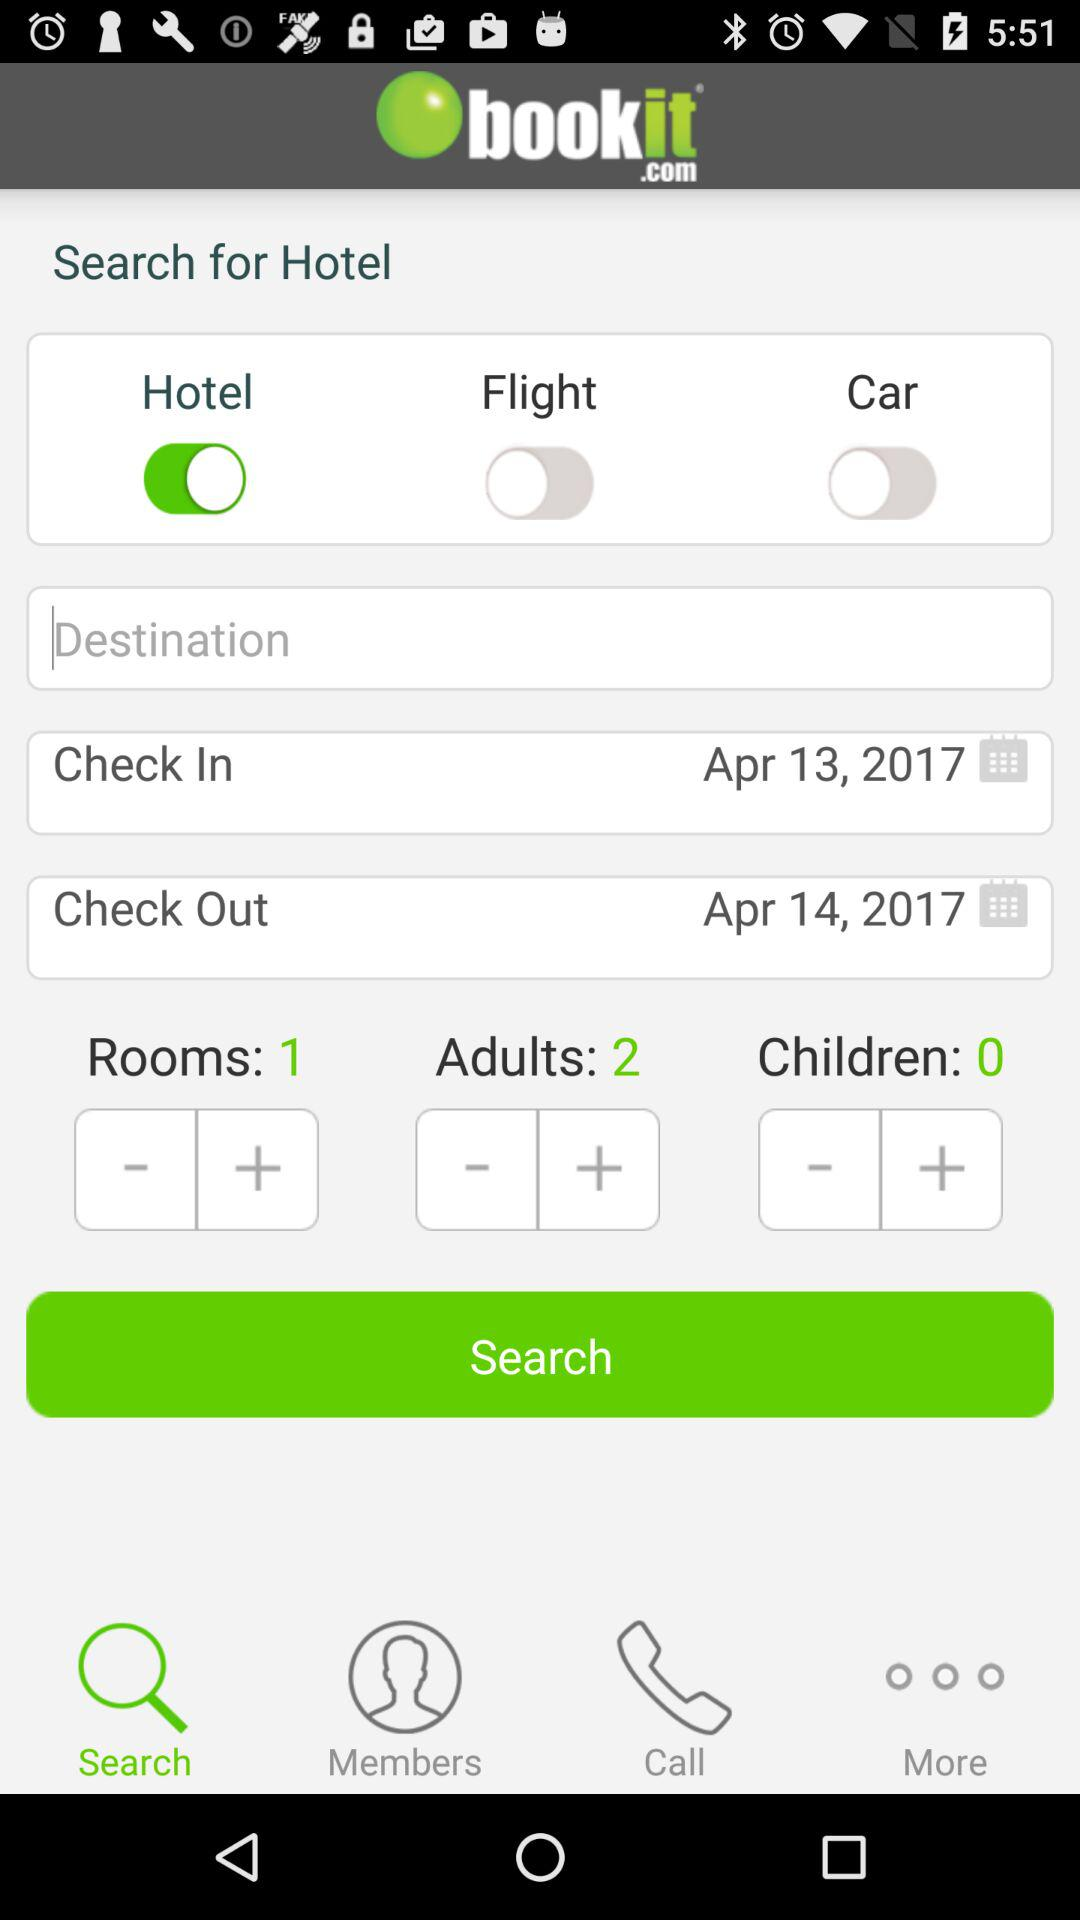What is the check-in date? The check-in date is April 13, 2017. 